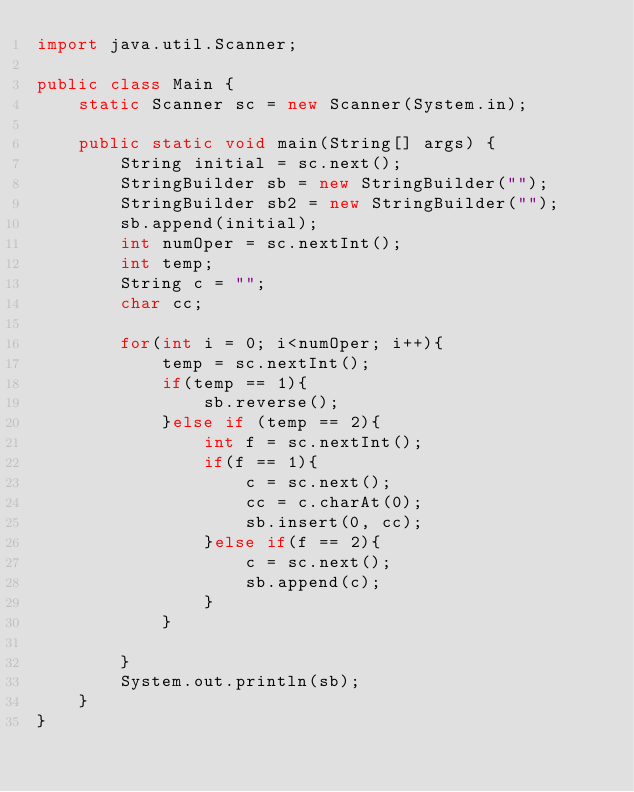<code> <loc_0><loc_0><loc_500><loc_500><_Java_>import java.util.Scanner;

public class Main {
    static Scanner sc = new Scanner(System.in);

    public static void main(String[] args) {
        String initial = sc.next();
        StringBuilder sb = new StringBuilder("");
        StringBuilder sb2 = new StringBuilder("");
        sb.append(initial);
        int numOper = sc.nextInt();
        int temp;
        String c = "";
        char cc;

        for(int i = 0; i<numOper; i++){
            temp = sc.nextInt();
            if(temp == 1){
                sb.reverse();
            }else if (temp == 2){
                int f = sc.nextInt();
                if(f == 1){
                    c = sc.next();
                    cc = c.charAt(0);
                    sb.insert(0, cc);
                }else if(f == 2){
                    c = sc.next();
                    sb.append(c);
                }
            }

        }
        System.out.println(sb);
    }
}
</code> 